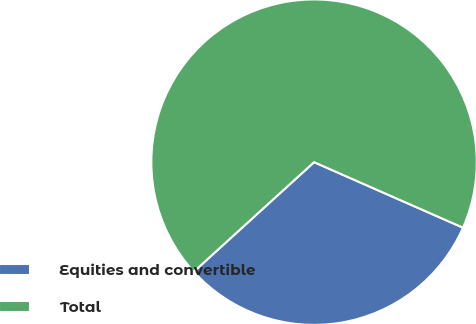<chart> <loc_0><loc_0><loc_500><loc_500><pie_chart><fcel>Equities and convertible<fcel>Total<nl><fcel>31.65%<fcel>68.35%<nl></chart> 